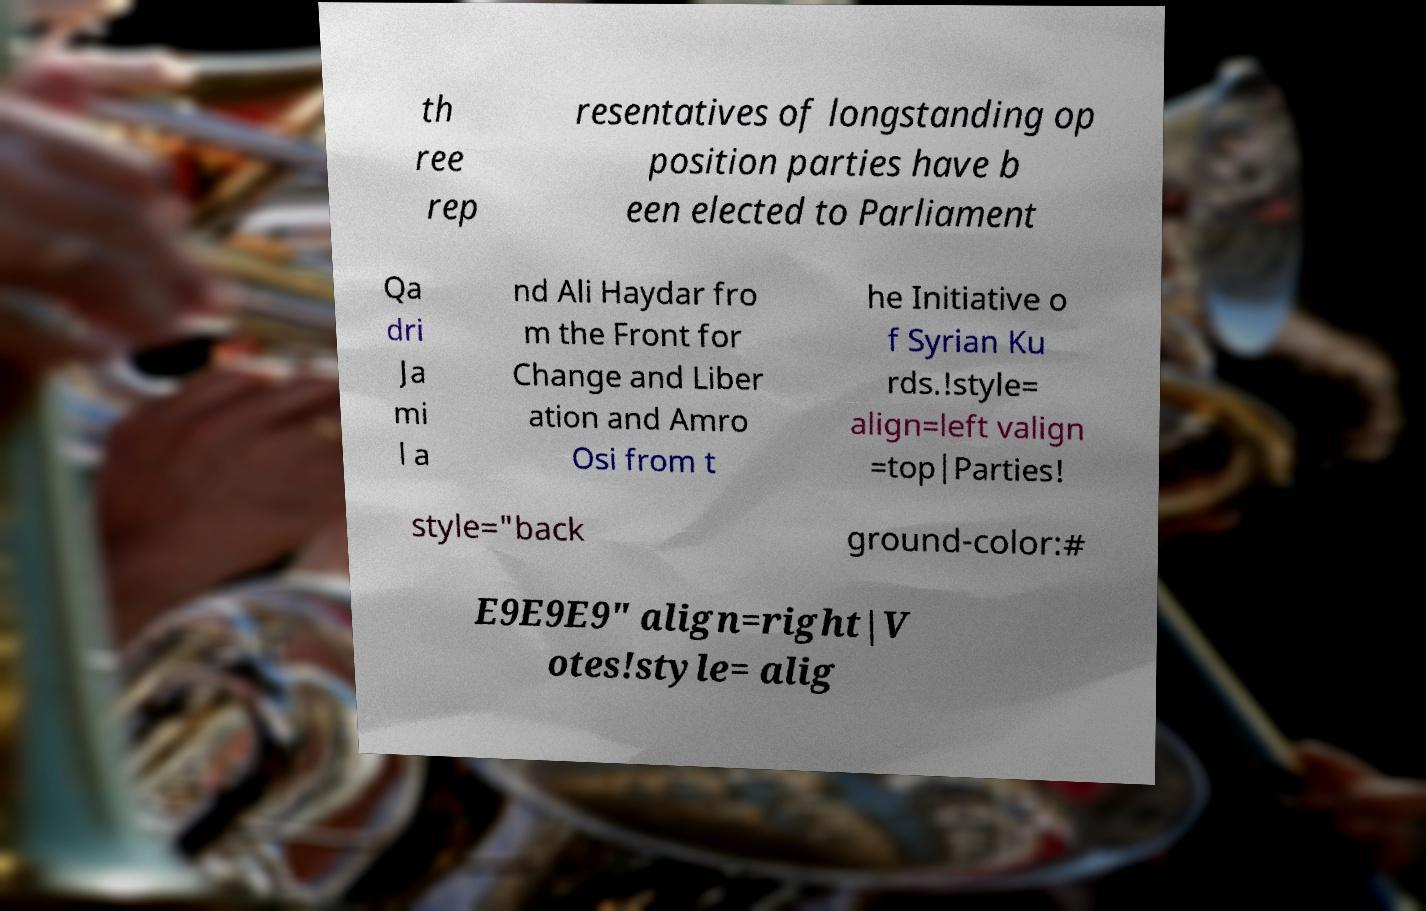What messages or text are displayed in this image? I need them in a readable, typed format. th ree rep resentatives of longstanding op position parties have b een elected to Parliament Qa dri Ja mi l a nd Ali Haydar fro m the Front for Change and Liber ation and Amro Osi from t he Initiative o f Syrian Ku rds.!style= align=left valign =top|Parties! style="back ground-color:# E9E9E9" align=right|V otes!style= alig 